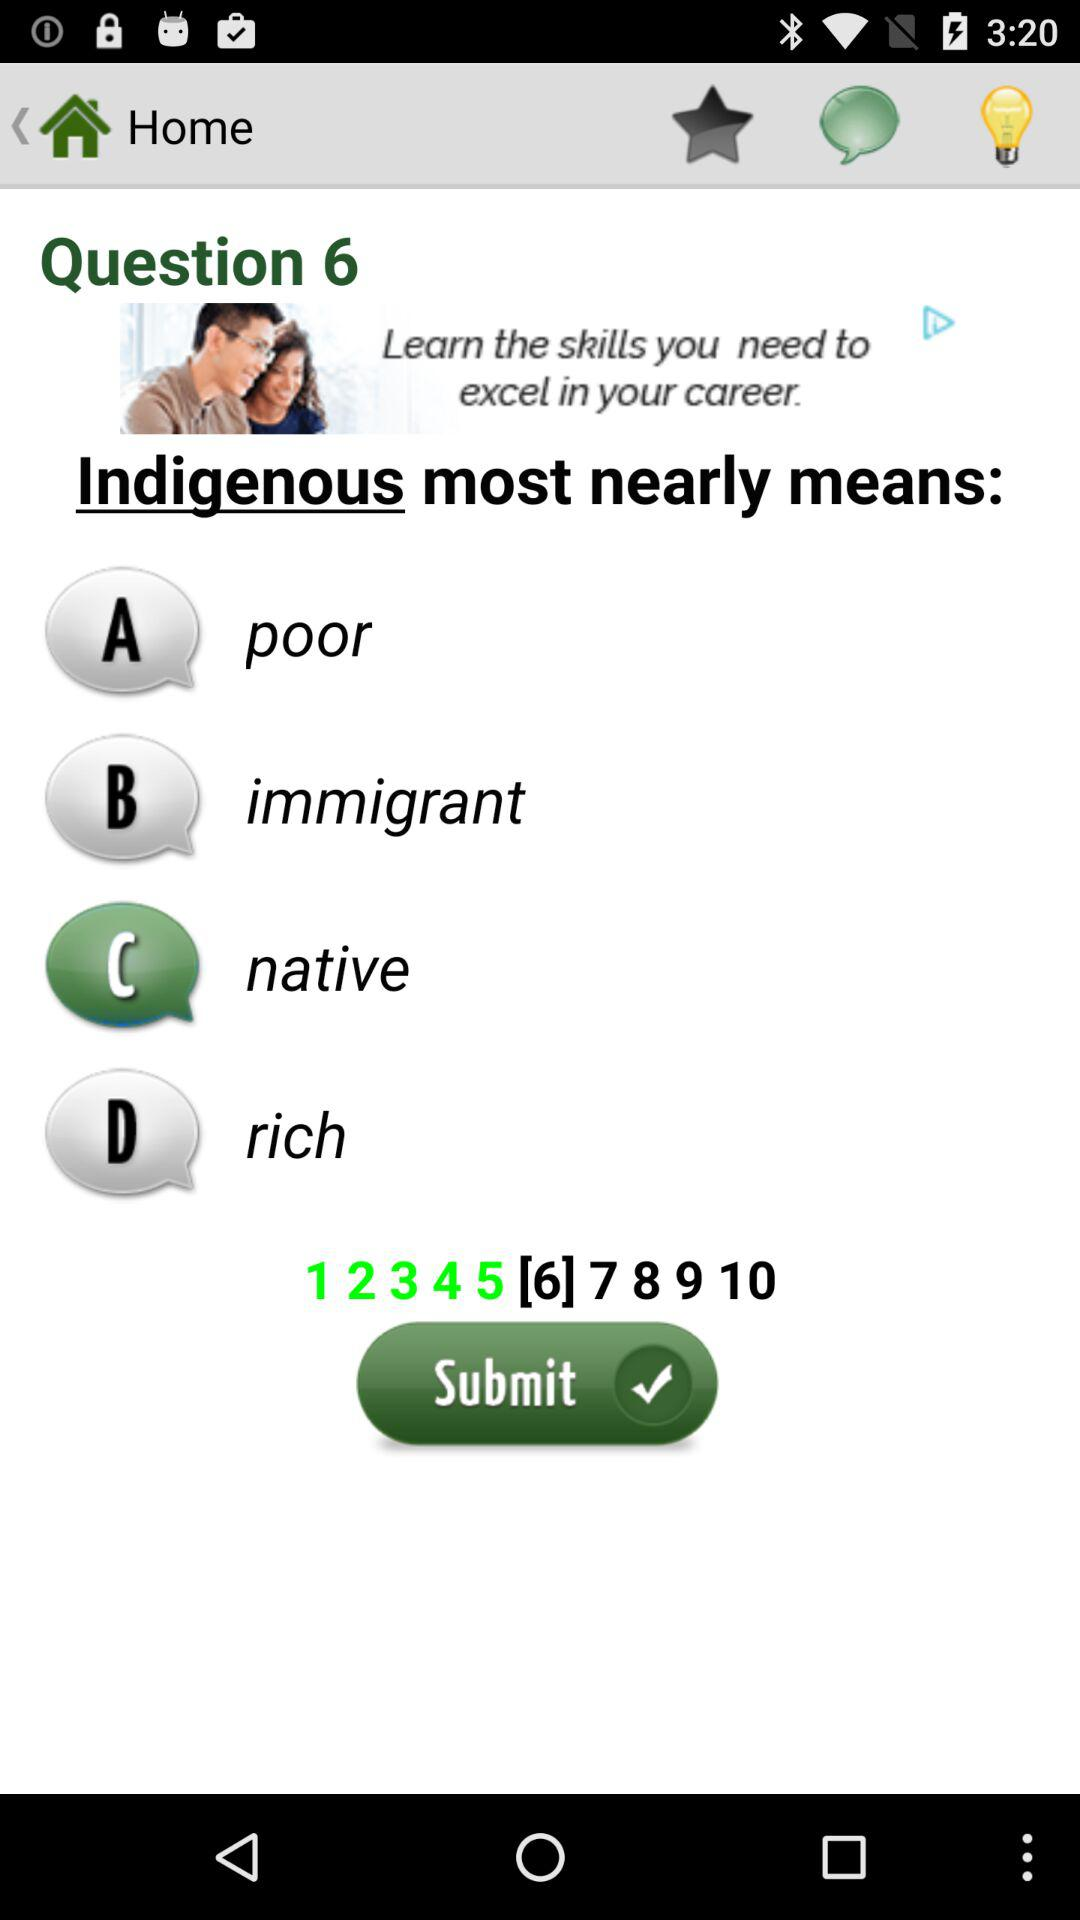What is the total number of questions? The total number of questions is 10. 